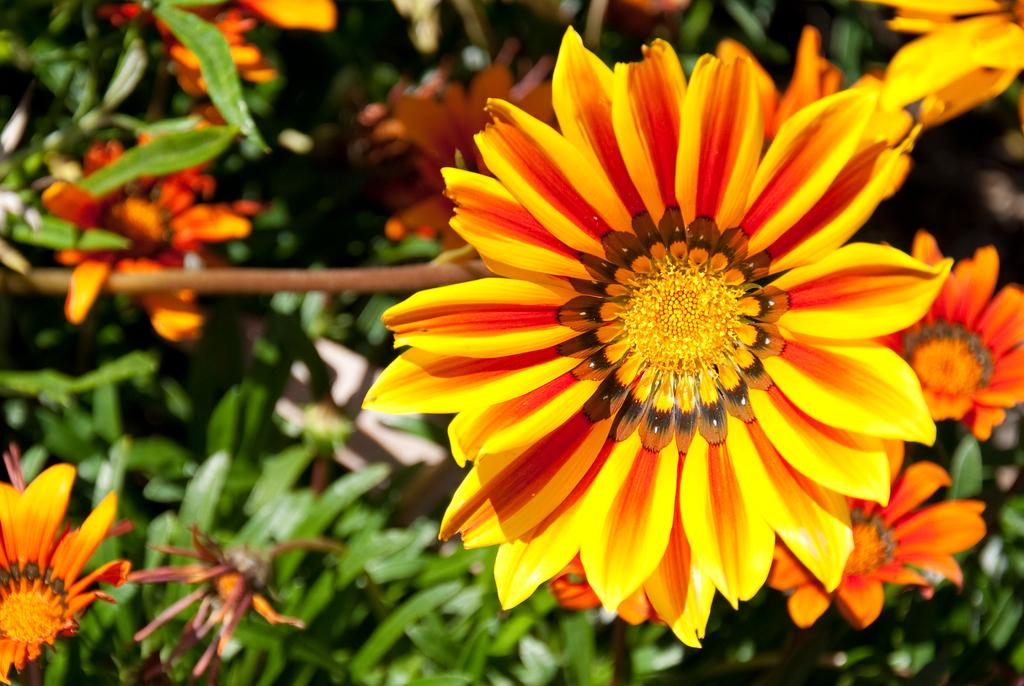What type of living organisms can be seen in the image? Plants can be seen in the image. What additional features can be observed on the plants? The plants have flowers. Where is the bomb hidden among the plants in the image? There is no bomb present in the image; it only features plants with flowers. 